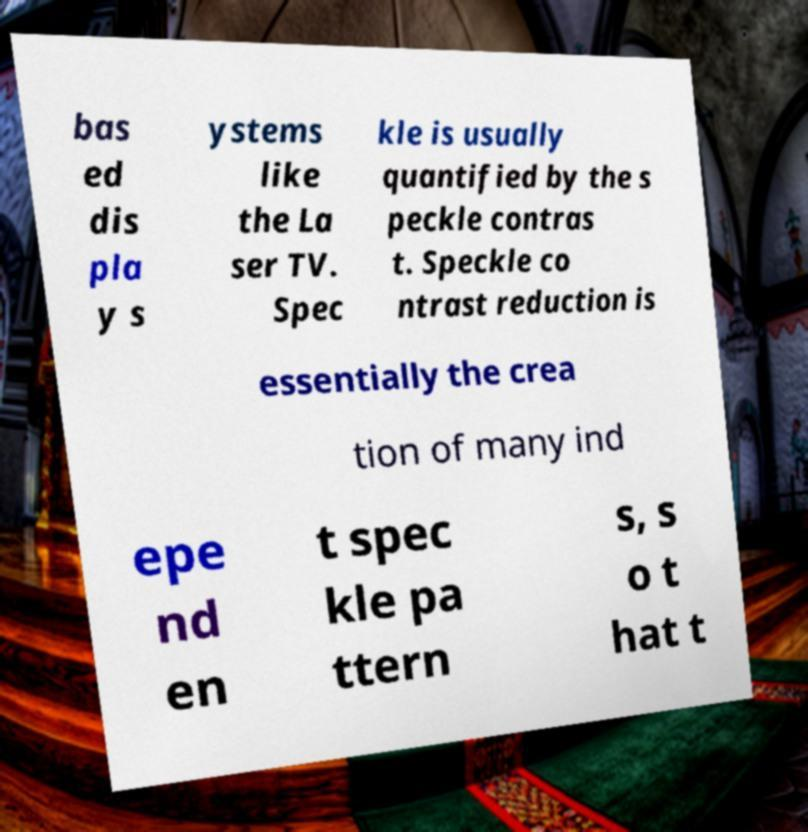Please identify and transcribe the text found in this image. bas ed dis pla y s ystems like the La ser TV. Spec kle is usually quantified by the s peckle contras t. Speckle co ntrast reduction is essentially the crea tion of many ind epe nd en t spec kle pa ttern s, s o t hat t 